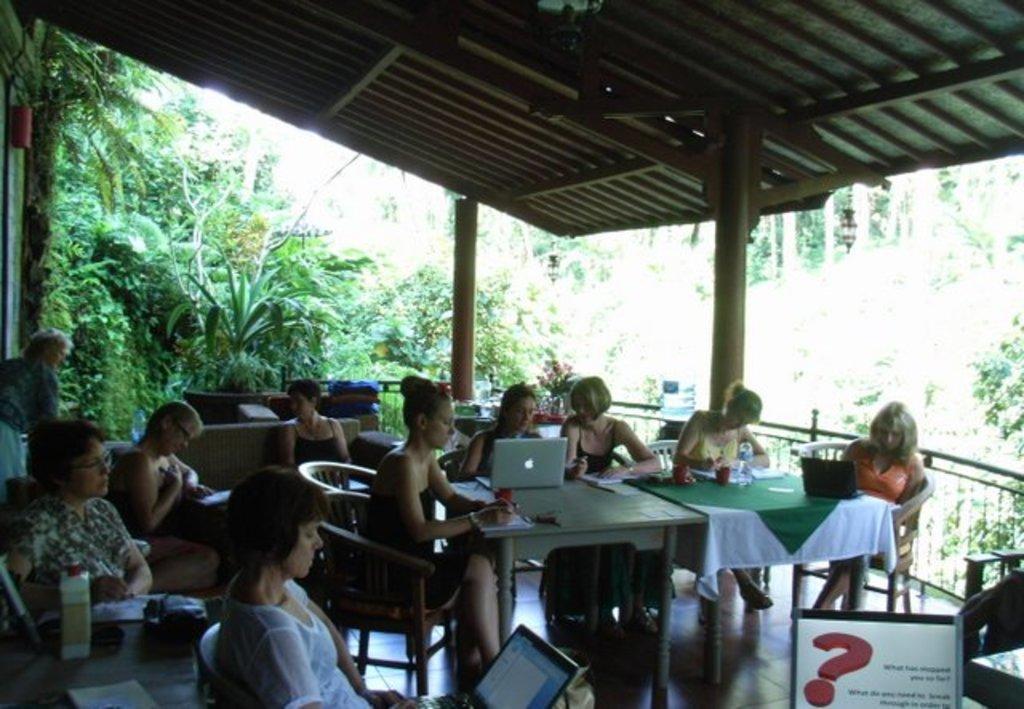Describe this image in one or two sentences. This picture describes about group of people few are seated on the chair, and few are standing in front of them we can find couple of laptops, bottles, glasses on the tables, in the background we can see trees and couple of lights. 